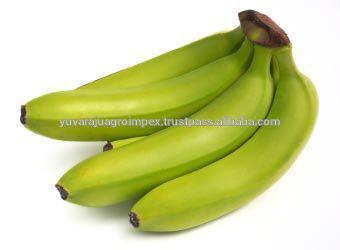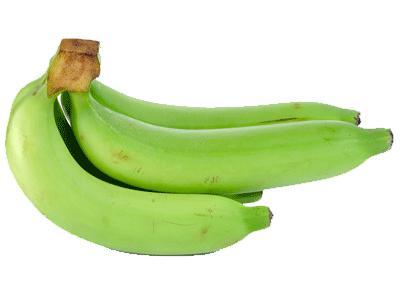The first image is the image on the left, the second image is the image on the right. Analyze the images presented: Is the assertion "The ends of the bananas in both pictures are pointing in opposite directions." valid? Answer yes or no. Yes. 